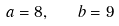Convert formula to latex. <formula><loc_0><loc_0><loc_500><loc_500>a = 8 , \quad b = 9</formula> 